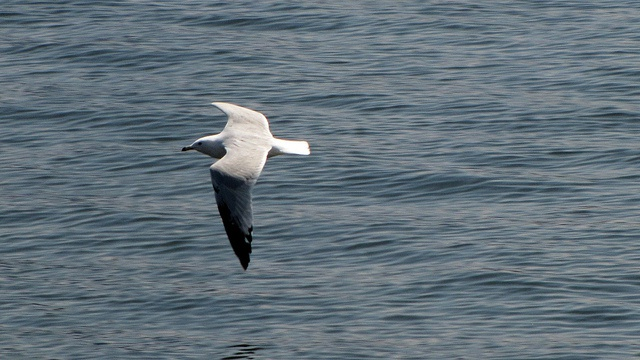Describe the objects in this image and their specific colors. I can see a bird in gray, black, lightgray, and darkgray tones in this image. 